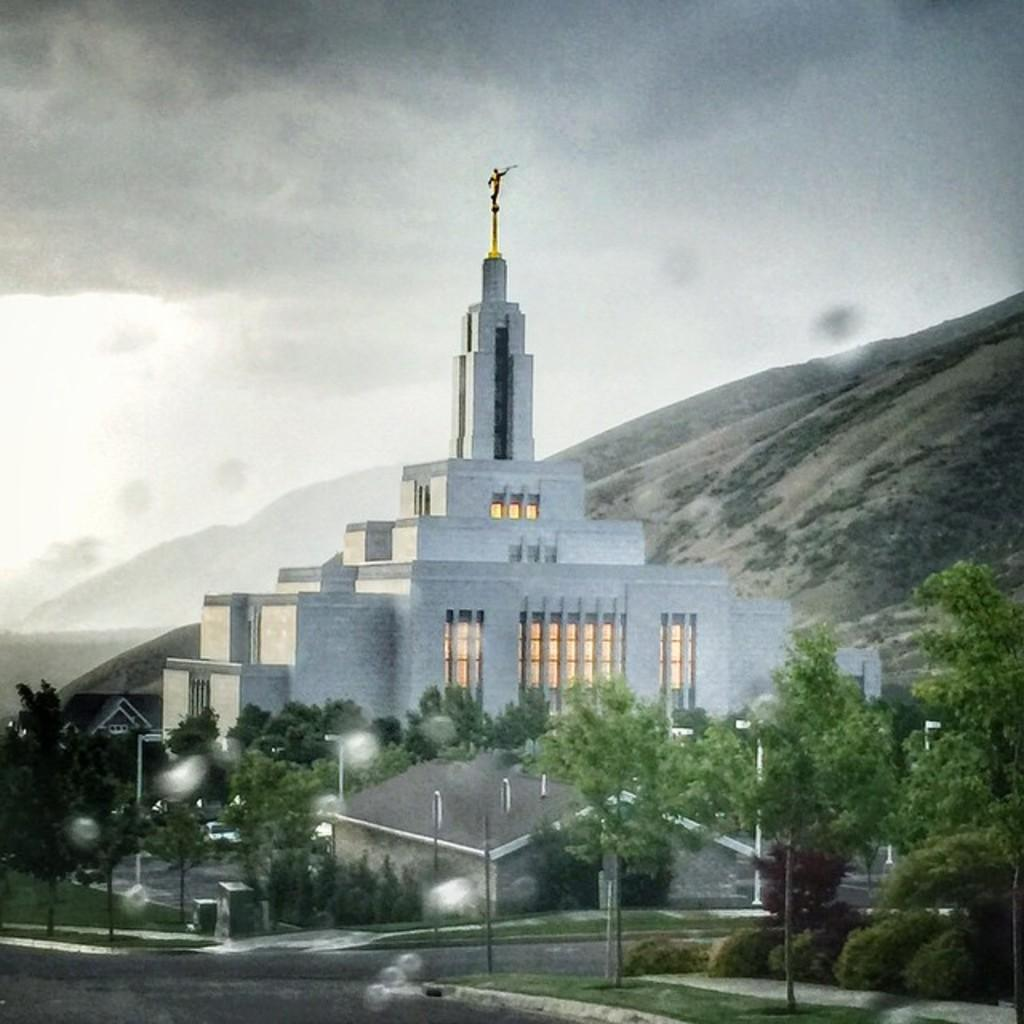What is the main subject of the image? There is a building at the center of the image. What can be seen in front of the building? There are trees and street lights in front of the building. What is visible in the background of the image? There is a mountain and the sky in the background of the image. What type of beast is sitting on the judge's chair in the image? There is no beast or judge present in the image; it features a building, trees, street lights, a mountain, and the sky. 